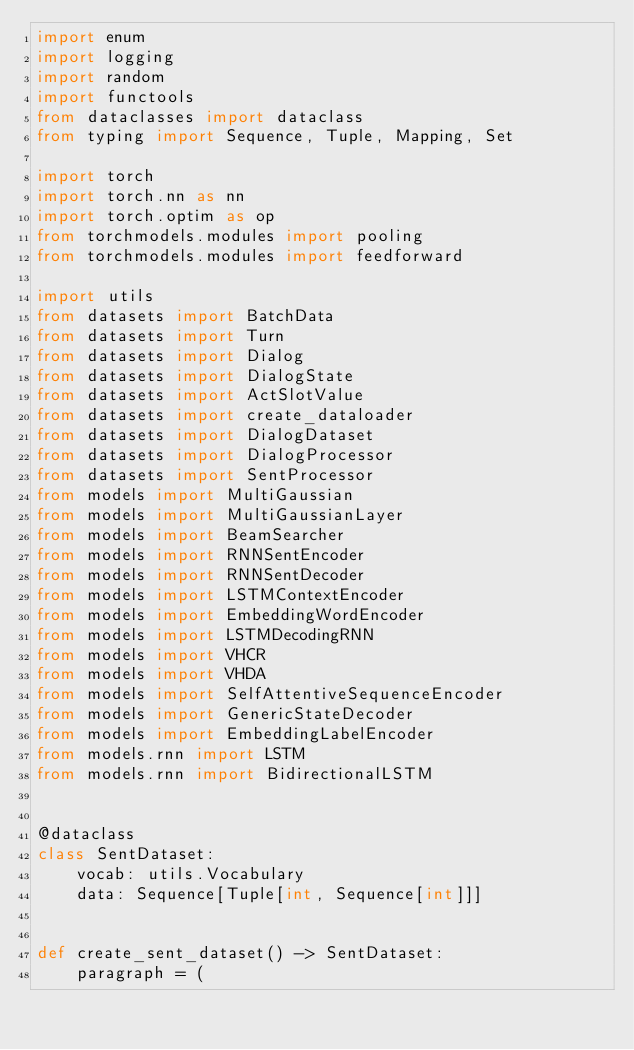Convert code to text. <code><loc_0><loc_0><loc_500><loc_500><_Python_>import enum
import logging
import random
import functools
from dataclasses import dataclass
from typing import Sequence, Tuple, Mapping, Set

import torch
import torch.nn as nn
import torch.optim as op
from torchmodels.modules import pooling
from torchmodels.modules import feedforward

import utils
from datasets import BatchData
from datasets import Turn
from datasets import Dialog
from datasets import DialogState
from datasets import ActSlotValue
from datasets import create_dataloader
from datasets import DialogDataset
from datasets import DialogProcessor
from datasets import SentProcessor
from models import MultiGaussian
from models import MultiGaussianLayer
from models import BeamSearcher
from models import RNNSentEncoder
from models import RNNSentDecoder
from models import LSTMContextEncoder
from models import EmbeddingWordEncoder
from models import LSTMDecodingRNN
from models import VHCR
from models import VHDA
from models import SelfAttentiveSequenceEncoder
from models import GenericStateDecoder
from models import EmbeddingLabelEncoder
from models.rnn import LSTM
from models.rnn import BidirectionalLSTM


@dataclass
class SentDataset:
    vocab: utils.Vocabulary
    data: Sequence[Tuple[int, Sequence[int]]]


def create_sent_dataset() -> SentDataset:
    paragraph = (</code> 